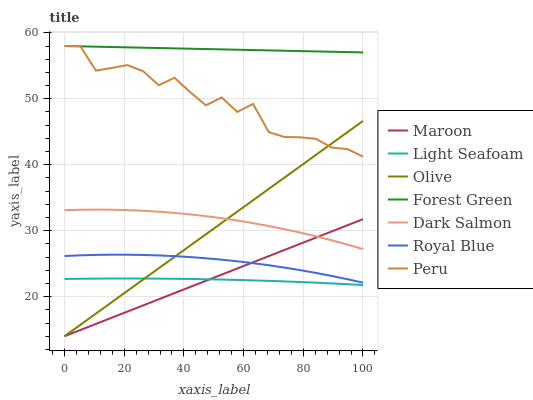Does Maroon have the minimum area under the curve?
Answer yes or no. No. Does Maroon have the maximum area under the curve?
Answer yes or no. No. Is Royal Blue the smoothest?
Answer yes or no. No. Is Royal Blue the roughest?
Answer yes or no. No. Does Royal Blue have the lowest value?
Answer yes or no. No. Does Maroon have the highest value?
Answer yes or no. No. Is Light Seafoam less than Dark Salmon?
Answer yes or no. Yes. Is Dark Salmon greater than Light Seafoam?
Answer yes or no. Yes. Does Light Seafoam intersect Dark Salmon?
Answer yes or no. No. 